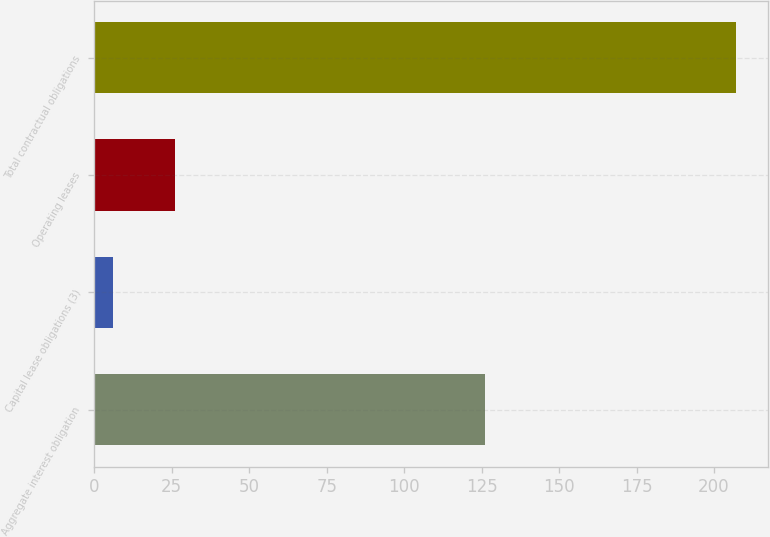Convert chart. <chart><loc_0><loc_0><loc_500><loc_500><bar_chart><fcel>Aggregate interest obligation<fcel>Capital lease obligations (3)<fcel>Operating leases<fcel>Total contractual obligations<nl><fcel>126<fcel>6<fcel>26.1<fcel>207<nl></chart> 